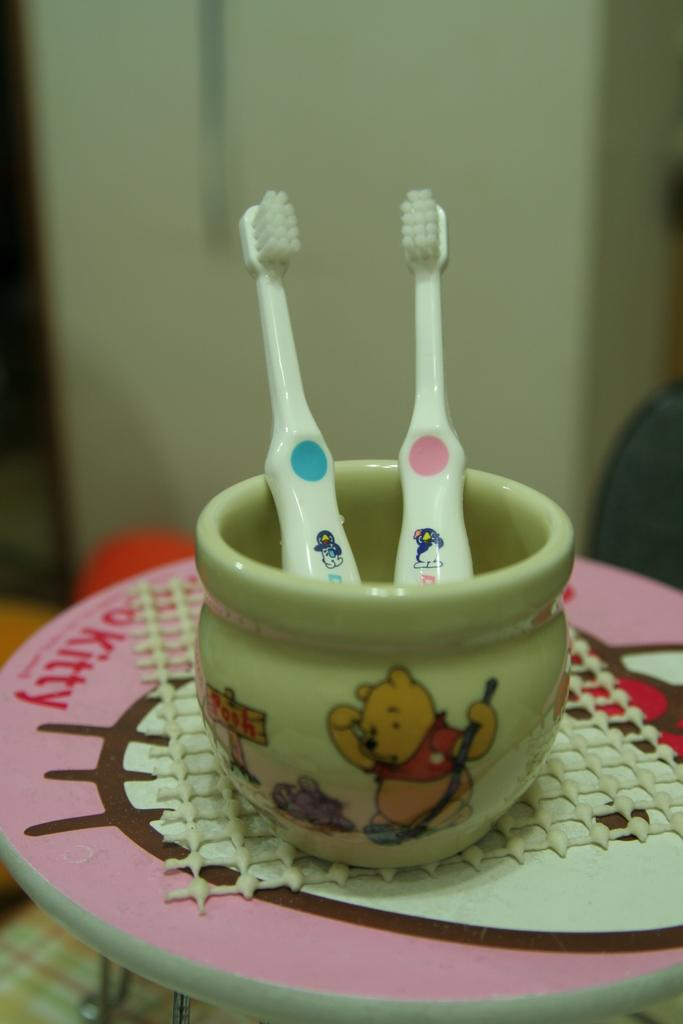What is in the bowl that is visible in the image? The bowl contains two brushes in the image. Where is the bowl located? The bowl is on a mat in the image. What is the mat placed on? The mat is on a stool in the image. What can be seen in the background of the image? There is a wall in the background of the image. What type of hospital equipment can be seen in the image? There is no hospital equipment present in the image; it features a bowl with two brushes on a mat on a stool. What type of vacation destination is depicted in the image? There is no vacation destination depicted in the image; it features a bowl with two brushes on a mat on a stool. 